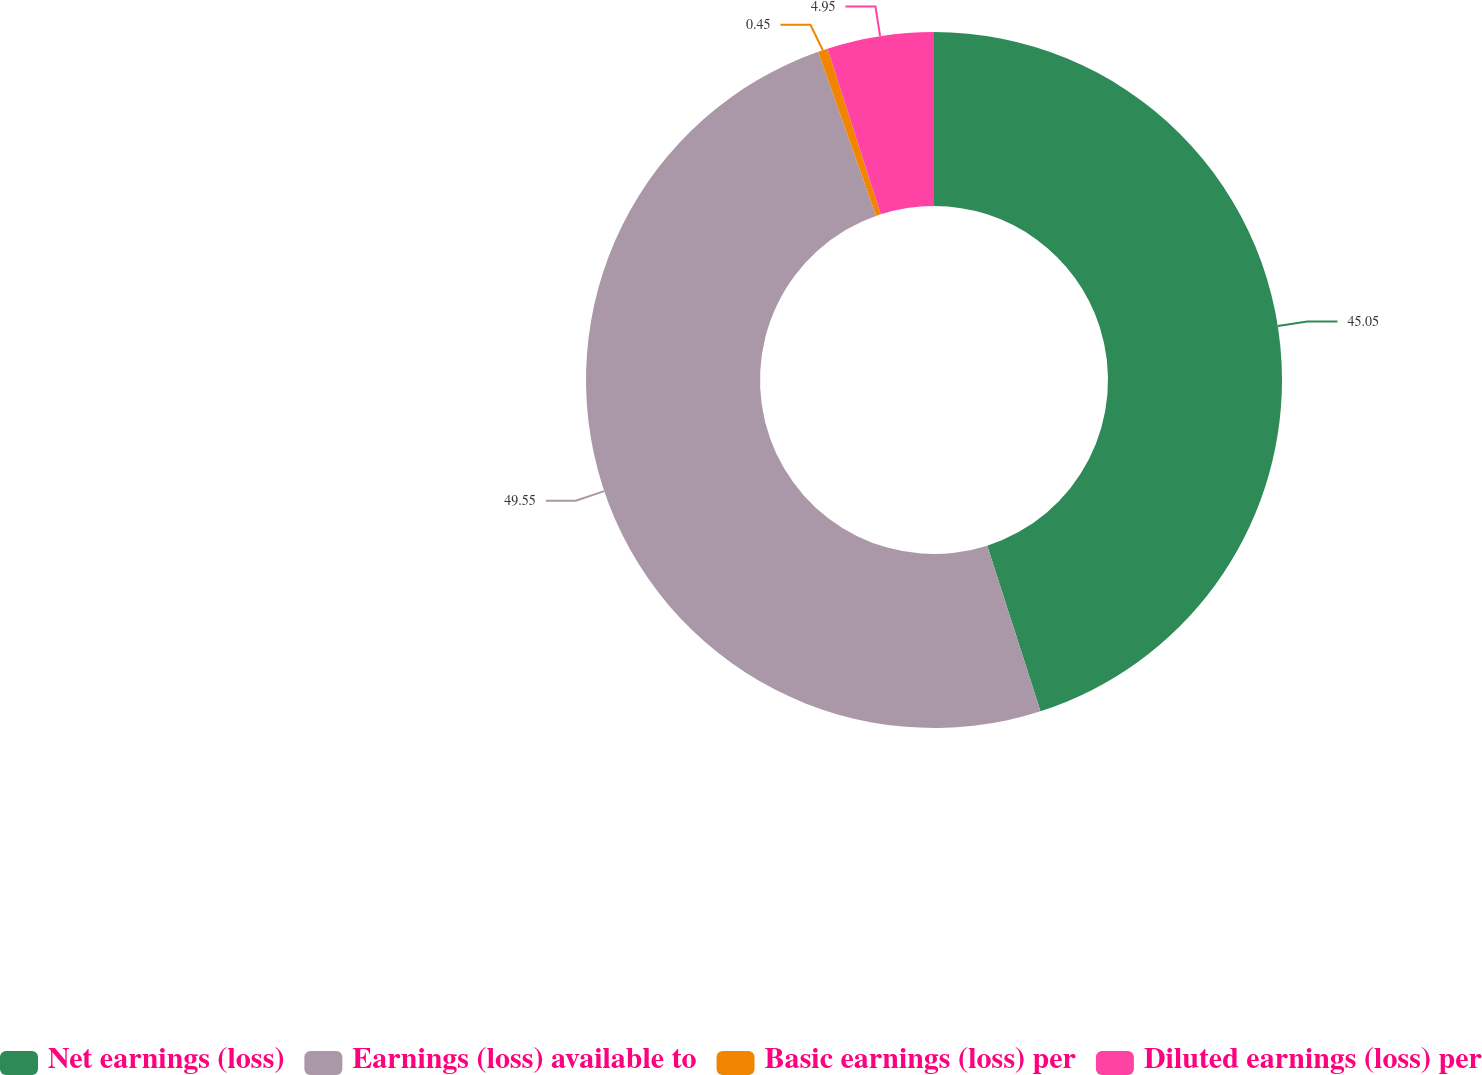Convert chart to OTSL. <chart><loc_0><loc_0><loc_500><loc_500><pie_chart><fcel>Net earnings (loss)<fcel>Earnings (loss) available to<fcel>Basic earnings (loss) per<fcel>Diluted earnings (loss) per<nl><fcel>45.05%<fcel>49.55%<fcel>0.45%<fcel>4.95%<nl></chart> 